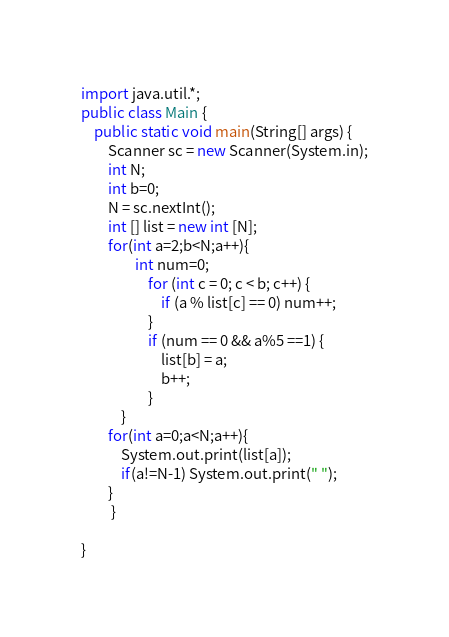<code> <loc_0><loc_0><loc_500><loc_500><_Java_>import java.util.*;
public class Main {
    public static void main(String[] args) {
        Scanner sc = new Scanner(System.in);
        int N;
        int b=0;
        N = sc.nextInt();
        int [] list = new int [N];
        for(int a=2;b<N;a++){
                int num=0;
                    for (int c = 0; c < b; c++) {
                        if (a % list[c] == 0) num++;
                    }
                    if (num == 0 && a%5 ==1) {
                        list[b] = a;
                        b++;
                    }
            }
        for(int a=0;a<N;a++){
            System.out.print(list[a]);
            if(a!=N-1) System.out.print(" ");
        }
         }

}</code> 